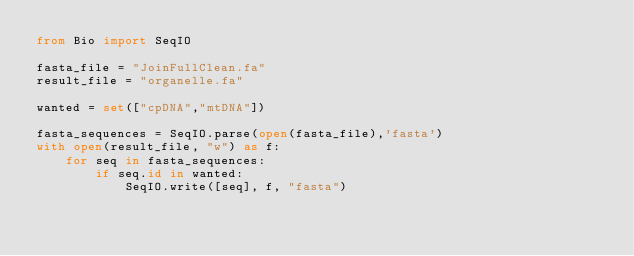Convert code to text. <code><loc_0><loc_0><loc_500><loc_500><_Python_>from Bio import SeqIO

fasta_file = "JoinFullClean.fa"
result_file = "organelle.fa"

wanted = set(["cpDNA","mtDNA"])

fasta_sequences = SeqIO.parse(open(fasta_file),'fasta')
with open(result_file, "w") as f:
    for seq in fasta_sequences:
        if seq.id in wanted:
            SeqIO.write([seq], f, "fasta")
</code> 